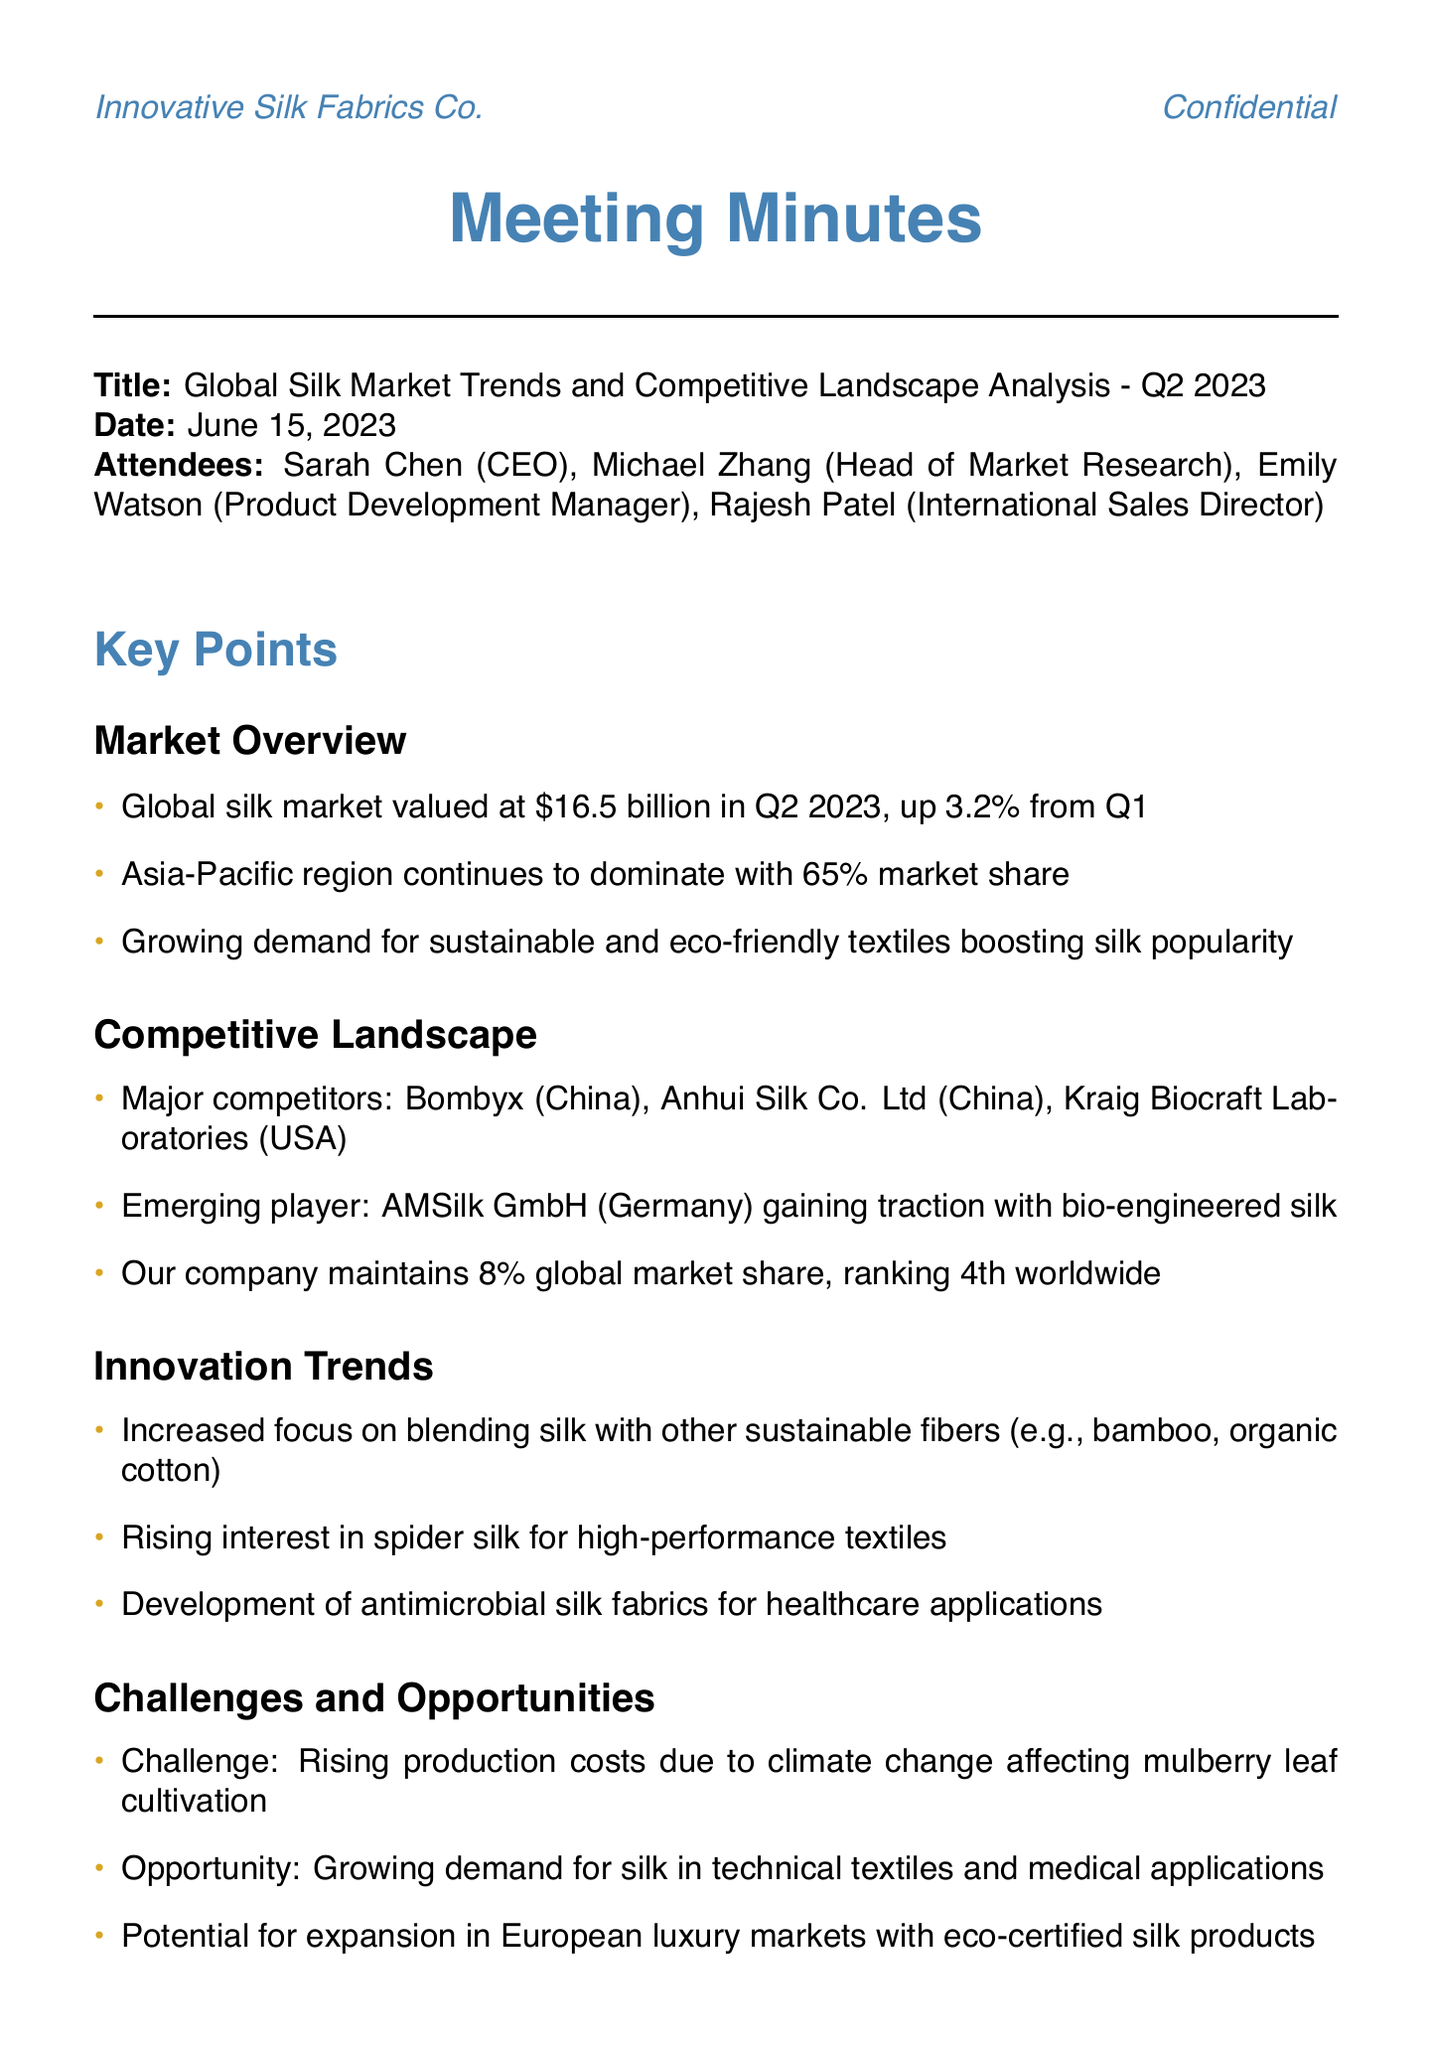What was the global silk market value in Q2 2023? The global silk market value in Q2 2023 is stated directly in the document.
Answer: $16.5 billion Which region holds the largest market share for silk? The document mentions the region that dominates the market.
Answer: Asia-Pacific What was the market share percentage for our company? The document provides specific market share information for the company.
Answer: 8% Who is an emerging player in the silk market? The document identifies a company as an emerging player in the competitive landscape.
Answer: AMSilk GmbH What challenge is impacting production costs? The document outlines a specific challenge related to production costs.
Answer: Climate change What opportunity is highlighted for the silk market? The document lists a significant opportunity in the silk industry.
Answer: Growing demand for silk in technical textiles What is an action item regarding the R&D budget? The document details specific action items outlined in the meeting.
Answer: Increase R&D budget for sustainable silk production methods by 15% What is a potential market for expansion mentioned in the document? The document specifies an area where expansion is considered viable.
Answer: European luxury markets What is the interest in silk for healthcare applications? The document discusses a trend in product development related to silk.
Answer: Antimicrobial silk fabrics 